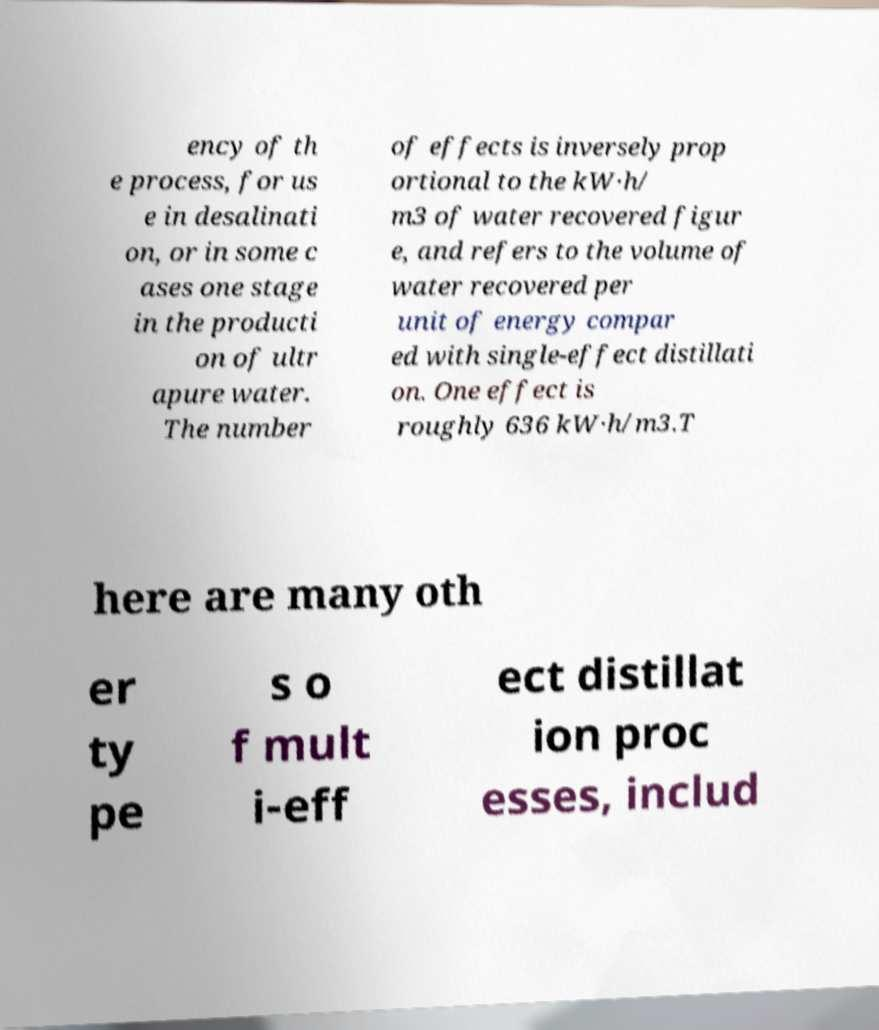Please identify and transcribe the text found in this image. ency of th e process, for us e in desalinati on, or in some c ases one stage in the producti on of ultr apure water. The number of effects is inversely prop ortional to the kW·h/ m3 of water recovered figur e, and refers to the volume of water recovered per unit of energy compar ed with single-effect distillati on. One effect is roughly 636 kW·h/m3.T here are many oth er ty pe s o f mult i-eff ect distillat ion proc esses, includ 